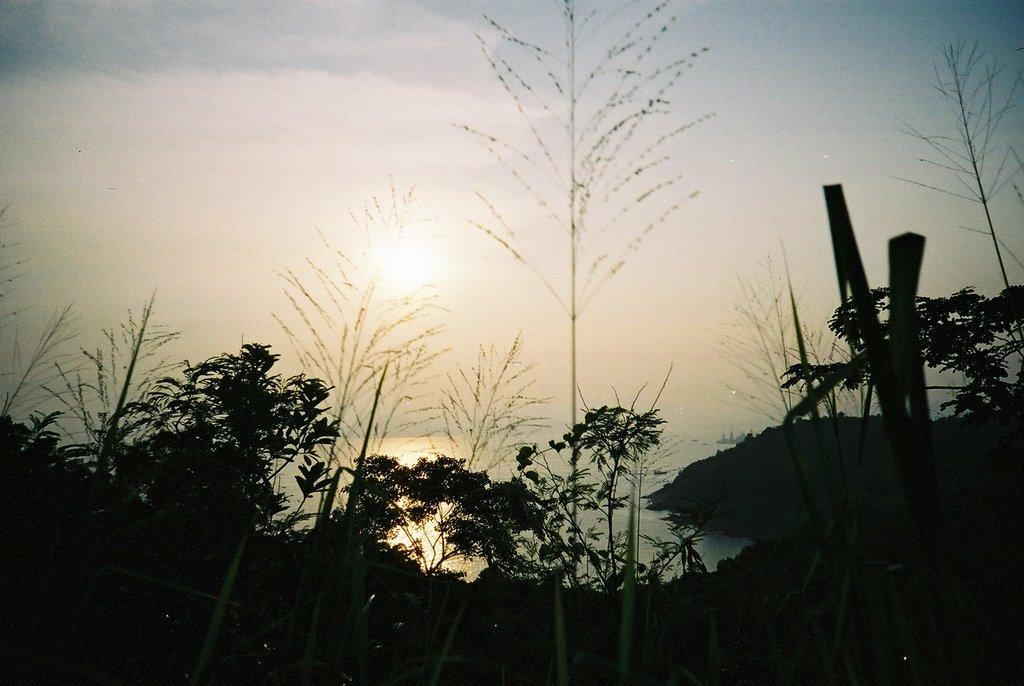What type of surface can be seen at the bottom of the image? The ground is visible in the image. What type of vegetation is present in the image? There are plants and trees in the image. What natural element is visible in the image? There is water visible in the image. What is visible in the sky in the image? The sky is visible in the image, and clouds and the sun are present. Reasoning: Let's think step by identifying the main subjects and objects in the image based on the provided facts. We then formulate questions that focus on the location and characteristics of these subjects and objects, ensuring that each question can be answered definitively with the information given. We avoid yes/no questions and ensure that the language is simple and clear. Absurd Question/Answer: Where are the children playing with their toothbrushes in the image? There are no children or toothbrushes present in the image. What type of needle is used to sew the plants in the image? There are no needles or sewing involved in the image; it features plants, trees, water, and a sky with clouds and the sun. What type of needle is used to sew the plants in the image? There are no needles or sewing involved in the image; it features plants, trees, water, and a sky with clouds and the sun. 